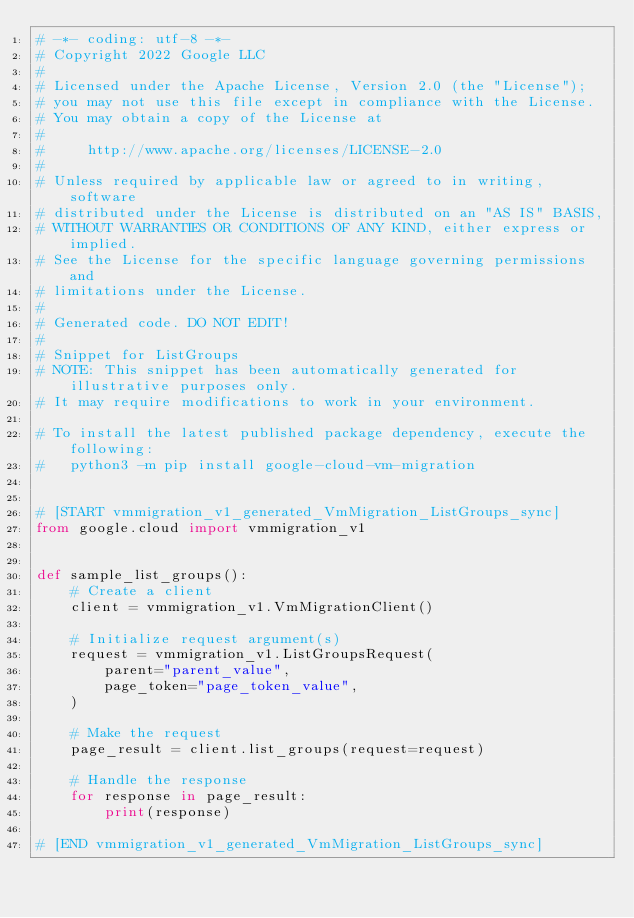Convert code to text. <code><loc_0><loc_0><loc_500><loc_500><_Python_># -*- coding: utf-8 -*-
# Copyright 2022 Google LLC
#
# Licensed under the Apache License, Version 2.0 (the "License");
# you may not use this file except in compliance with the License.
# You may obtain a copy of the License at
#
#     http://www.apache.org/licenses/LICENSE-2.0
#
# Unless required by applicable law or agreed to in writing, software
# distributed under the License is distributed on an "AS IS" BASIS,
# WITHOUT WARRANTIES OR CONDITIONS OF ANY KIND, either express or implied.
# See the License for the specific language governing permissions and
# limitations under the License.
#
# Generated code. DO NOT EDIT!
#
# Snippet for ListGroups
# NOTE: This snippet has been automatically generated for illustrative purposes only.
# It may require modifications to work in your environment.

# To install the latest published package dependency, execute the following:
#   python3 -m pip install google-cloud-vm-migration


# [START vmmigration_v1_generated_VmMigration_ListGroups_sync]
from google.cloud import vmmigration_v1


def sample_list_groups():
    # Create a client
    client = vmmigration_v1.VmMigrationClient()

    # Initialize request argument(s)
    request = vmmigration_v1.ListGroupsRequest(
        parent="parent_value",
        page_token="page_token_value",
    )

    # Make the request
    page_result = client.list_groups(request=request)

    # Handle the response
    for response in page_result:
        print(response)

# [END vmmigration_v1_generated_VmMigration_ListGroups_sync]
</code> 